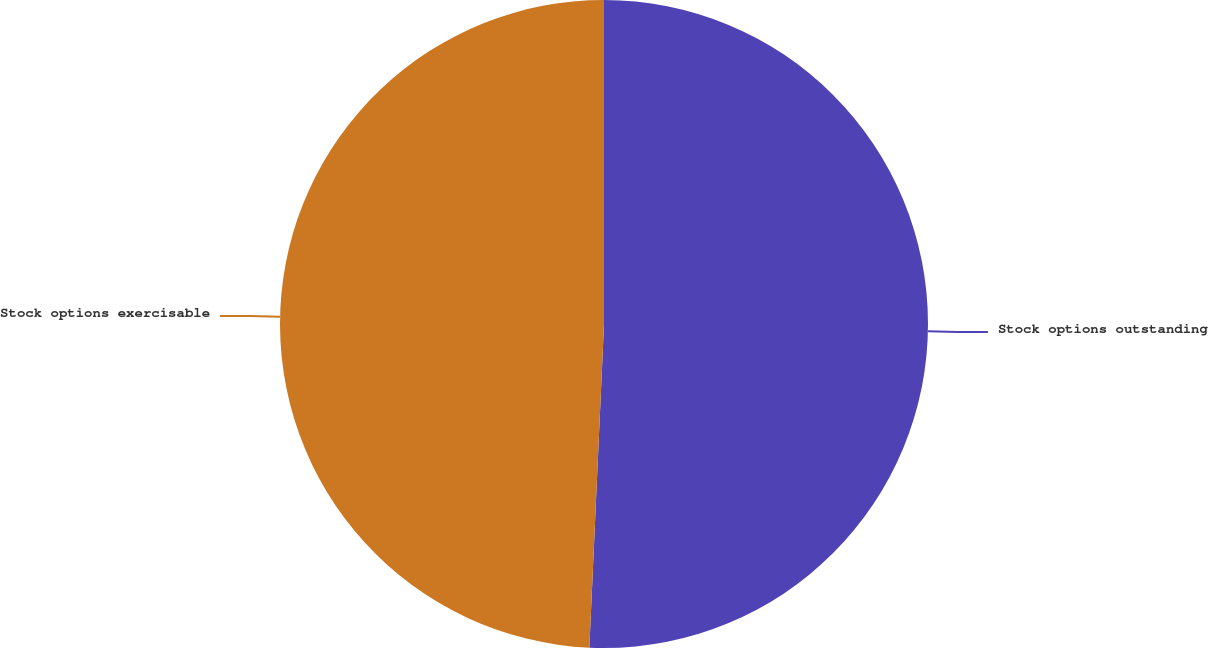<chart> <loc_0><loc_0><loc_500><loc_500><pie_chart><fcel>Stock options outstanding<fcel>Stock options exercisable<nl><fcel>50.72%<fcel>49.28%<nl></chart> 